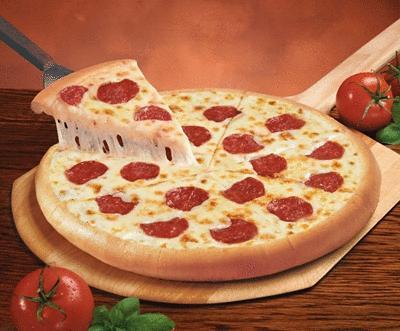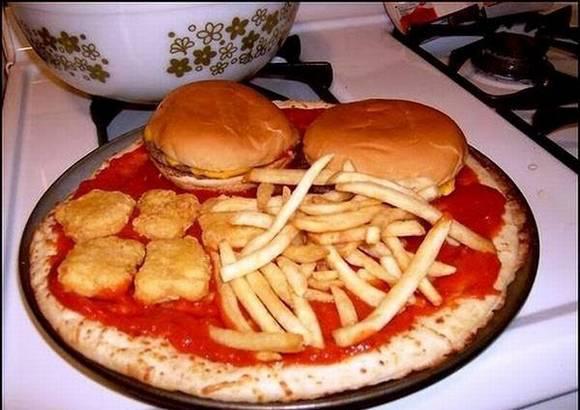The first image is the image on the left, the second image is the image on the right. Examine the images to the left and right. Is the description "One of the pizzas has hamburgers on top." accurate? Answer yes or no. Yes. The first image is the image on the left, the second image is the image on the right. For the images shown, is this caption "A pizza is topped with burgers, fries and nuggets." true? Answer yes or no. Yes. 